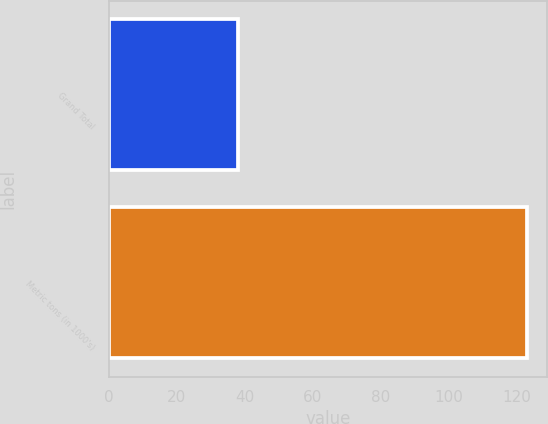Convert chart to OTSL. <chart><loc_0><loc_0><loc_500><loc_500><bar_chart><fcel>Grand Total<fcel>Metric tons (in 1000's)<nl><fcel>38<fcel>123<nl></chart> 